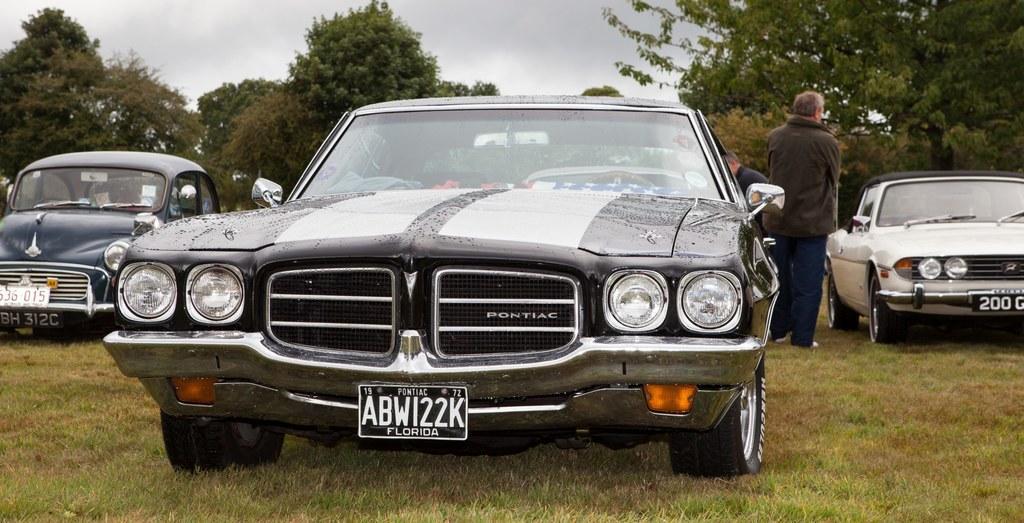Describe this image in one or two sentences. In this image I can see a car which is black and white in color on the ground. In the background I can see 2 other cars, few persons, few trees and the sky. 